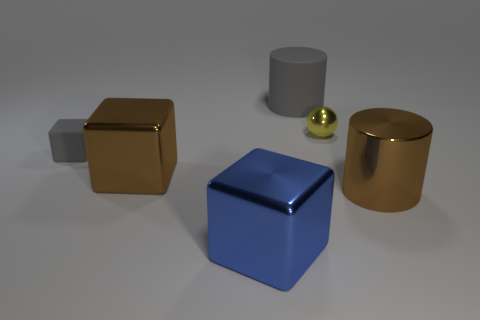What color is the tiny block that is the same material as the gray cylinder?
Provide a succinct answer. Gray. What number of big blue objects have the same material as the ball?
Your answer should be compact. 1. There is a large object behind the tiny block; is its color the same as the small shiny sphere?
Your response must be concise. No. How many blue metal objects are the same shape as the large gray rubber object?
Offer a terse response. 0. Are there the same number of large blue shiny objects that are on the left side of the blue metallic thing and brown rubber balls?
Your answer should be very brief. Yes. What is the color of the block that is the same size as the yellow shiny object?
Give a very brief answer. Gray. Are there any tiny things that have the same shape as the large gray rubber thing?
Give a very brief answer. No. The cube on the left side of the big brown object left of the big brown shiny thing that is to the right of the large brown metallic cube is made of what material?
Provide a short and direct response. Rubber. What number of other objects are the same size as the metal cylinder?
Offer a very short reply. 3. What color is the tiny rubber cube?
Your response must be concise. Gray. 